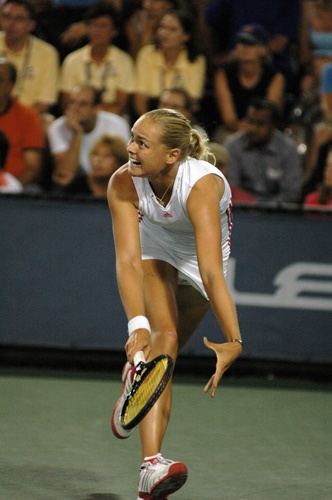Describe the objects in this image and their specific colors. I can see people in gray, olive, tan, and black tones, people in gray and black tones, people in gray, tan, black, and maroon tones, people in gray, black, maroon, and brown tones, and people in gray, tan, maroon, black, and olive tones in this image. 